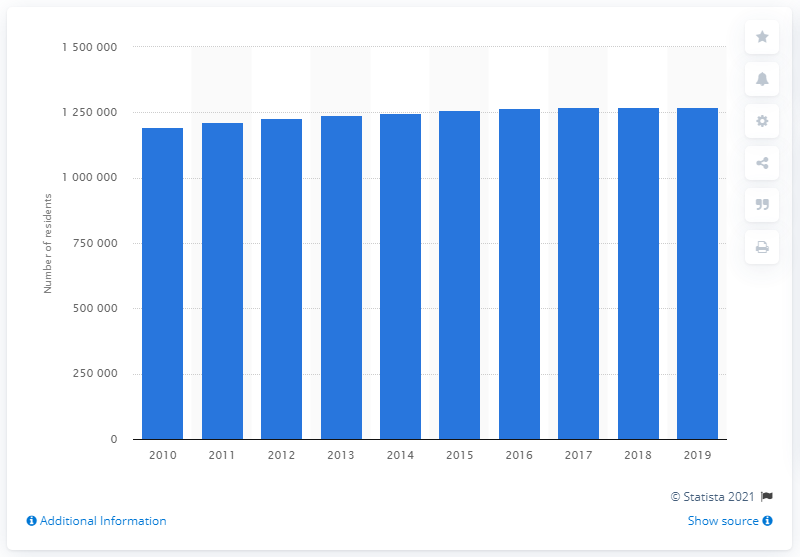Identify some key points in this picture. In 2019, the New Orleans-Metairie metropolitan area had a population of approximately 1,260,281 people. 